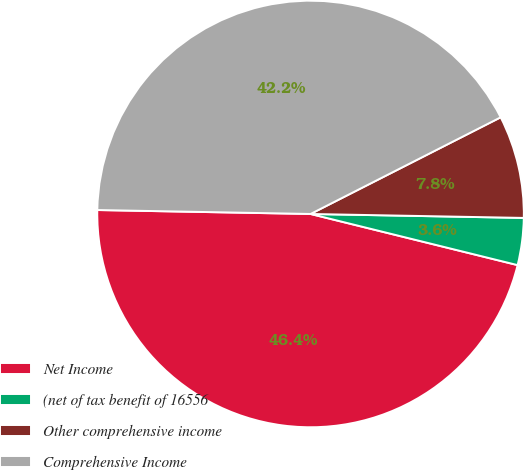<chart> <loc_0><loc_0><loc_500><loc_500><pie_chart><fcel>Net Income<fcel>(net of tax benefit of 16556<fcel>Other comprehensive income<fcel>Comprehensive Income<nl><fcel>46.44%<fcel>3.56%<fcel>7.78%<fcel>42.22%<nl></chart> 